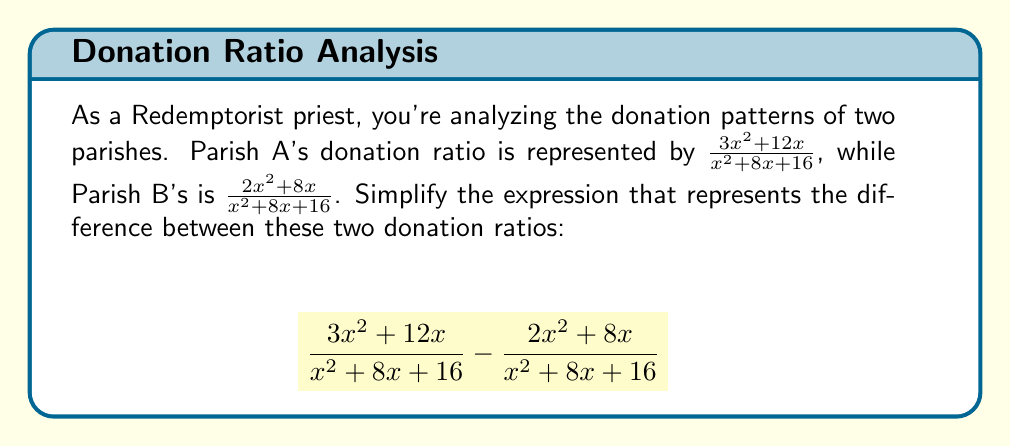What is the answer to this math problem? Let's simplify this expression step-by-step:

1) First, we notice that both fractions have the same denominator. When subtracting fractions with the same denominator, we can subtract the numerators and keep the denominator the same.

2) So, our expression becomes:
   $$\frac{(3x^2 + 12x) - (2x^2 + 8x)}{x^2 + 8x + 16}$$

3) Now, let's subtract the terms in the numerator:
   $$\frac{3x^2 + 12x - 2x^2 - 8x}{x^2 + 8x + 16}$$

4) Simplify the numerator:
   $$\frac{x^2 + 4x}{x^2 + 8x + 16}$$

5) Now, we can factor out the greatest common factor (GCF) from the numerator and denominator:
   The GCF of $x^2 + 4x$ is $x$
   The GCF of $x^2 + 8x + 16$ is 1 (no common factor)

   $$\frac{x(x + 4)}{x^2 + 8x + 16}$$

6) The denominator $x^2 + 8x + 16$ can be factored as a perfect square trinomial:
   $$\frac{x(x + 4)}{(x + 4)^2}$$

7) Now we can cancel the common factor $(x + 4)$ in the numerator and denominator:
   $$\frac{x}{x + 4}$$

This is the simplified expression.
Answer: $\frac{x}{x + 4}$ 